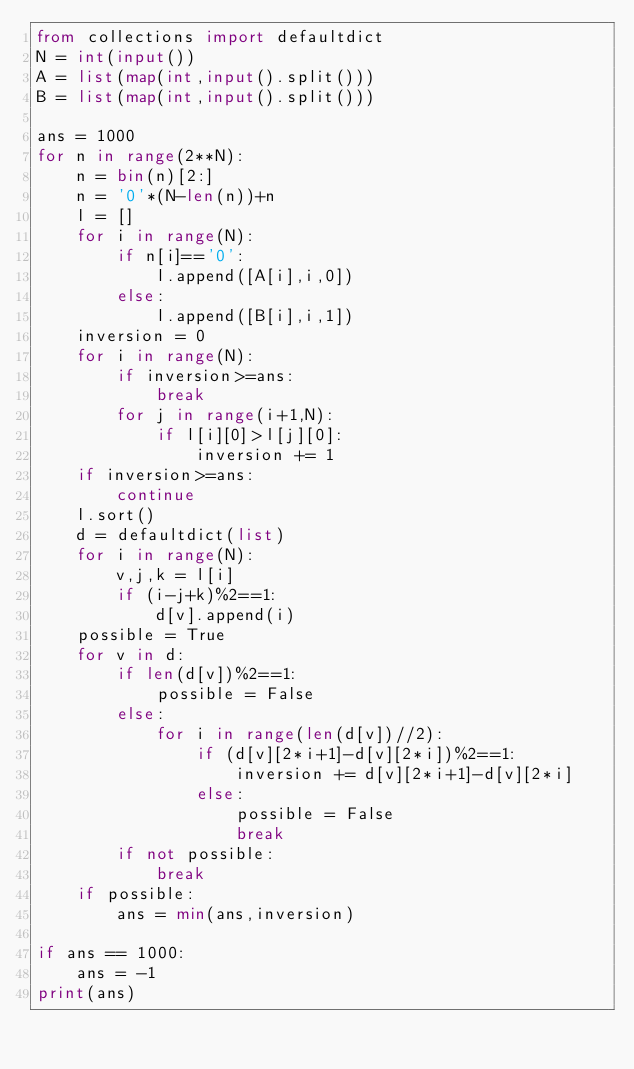<code> <loc_0><loc_0><loc_500><loc_500><_Python_>from collections import defaultdict
N = int(input())
A = list(map(int,input().split()))
B = list(map(int,input().split()))

ans = 1000
for n in range(2**N):
    n = bin(n)[2:]
    n = '0'*(N-len(n))+n
    l = []
    for i in range(N):
        if n[i]=='0':
            l.append([A[i],i,0])
        else:
            l.append([B[i],i,1])
    inversion = 0
    for i in range(N):
        if inversion>=ans:
            break
        for j in range(i+1,N):
            if l[i][0]>l[j][0]:
                inversion += 1
    if inversion>=ans:
        continue
    l.sort()
    d = defaultdict(list)
    for i in range(N):
        v,j,k = l[i]
        if (i-j+k)%2==1:
            d[v].append(i)
    possible = True
    for v in d:
        if len(d[v])%2==1:
            possible = False
        else:
            for i in range(len(d[v])//2):
                if (d[v][2*i+1]-d[v][2*i])%2==1:
                    inversion += d[v][2*i+1]-d[v][2*i]
                else:
                    possible = False
                    break
        if not possible:
            break
    if possible:
        ans = min(ans,inversion)

if ans == 1000:
    ans = -1
print(ans)</code> 